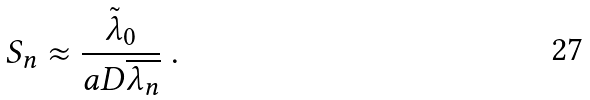<formula> <loc_0><loc_0><loc_500><loc_500>S _ { n } \approx \frac { \tilde { \lambda } _ { 0 } } { a D \overline { \lambda _ { n } } } \ .</formula> 